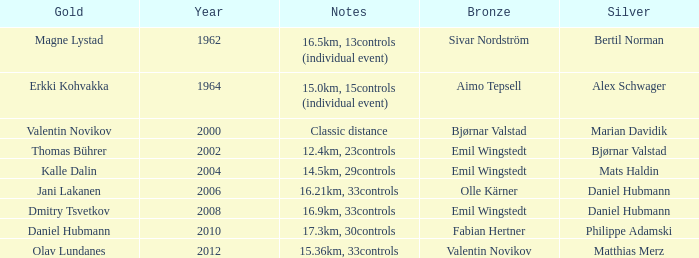WHAT YEAR HAS A SILVER FOR MATTHIAS MERZ? 2012.0. 